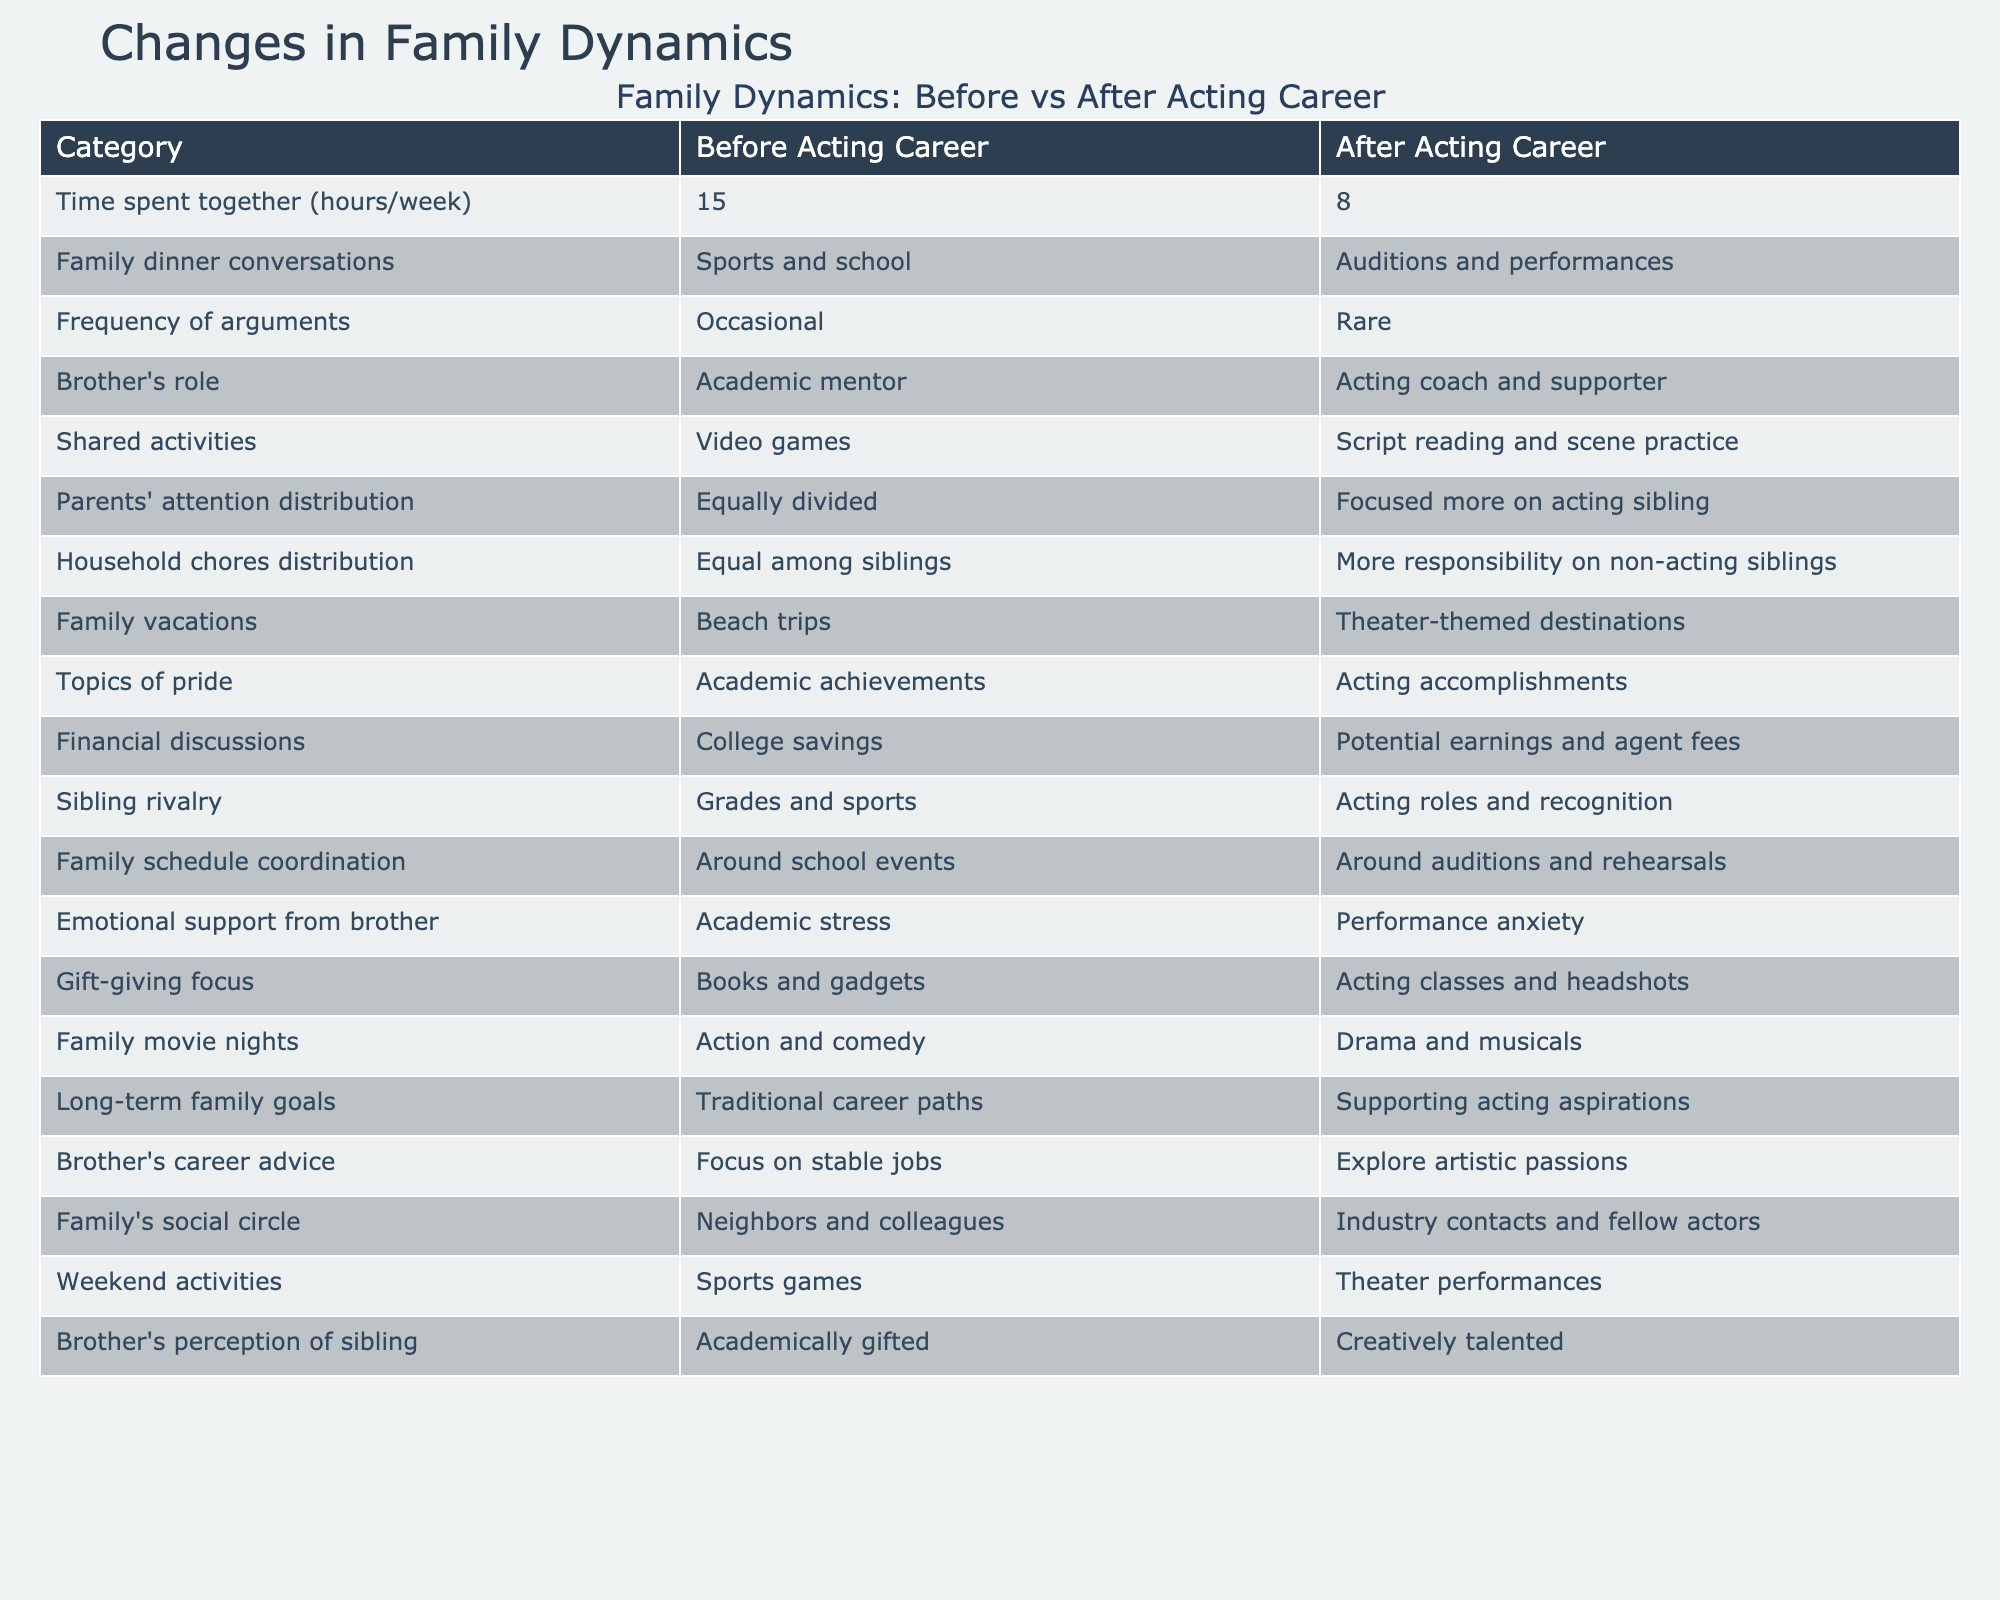What was the time spent together (hours/week) before the acting career? The table shows "15" under the "Before Acting Career" column for the "Time spent together (hours/week)" category.
Answer: 15 What are the main topics of family dinner conversations after the acting career? The table lists "Auditions and performances" under the "After Acting Career" column for the "Family dinner conversations" category.
Answer: Auditions and performances Was the frequency of arguments more before or after the acting career? According to the table, the frequency of arguments was "Occasional" before the acting career and "Rare" after, indicating fewer arguments after the career began.
Answer: After the acting career How did the distribution of parents' attention change after the acting career? The table indicates that parents' attention was "Equally divided" before and "Focused more on acting sibling" after the acting career, showing a shift in focus.
Answer: Focused more on acting sibling What responsibilities increased for non-acting siblings after the student began their acting career? The table states that the "Household chores distribution" shifted from "Equal among siblings" before to "More responsibility on non-acting siblings" after the acting career started.
Answer: More responsibility on non-acting siblings How many more hours were spent together each week before the acting career compared to after? Before the acting career, 15 hours were spent together, and after, it was 8 hours. The difference is 15 - 8 = 7 hours.
Answer: 7 hours Did family vacations change in theme after the acting career? Yes, the table shows that family vacations went from "Beach trips" before to "Theater-themed destinations" after the acting career began.
Answer: Yes What was the focus of gift-giving before the acting career? The "Gift-giving focus" category in the table shows "Books and gadgets" before the acting career.
Answer: Books and gadgets After the acting career, what were the emotional support dynamics regarding performance anxiety? The table lists "Academic stress" before and "Performance anxiety" after for the "Emotional support from brother" category, indicating a shift in the type of support needed.
Answer: Performance anxiety 